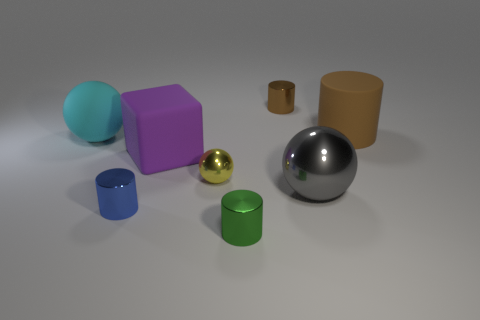What is the shape of the brown thing that is to the left of the gray metal object?
Ensure brevity in your answer.  Cylinder. Are there fewer large rubber cylinders than large yellow rubber things?
Keep it short and to the point. No. Is there anything else of the same color as the large cylinder?
Your response must be concise. Yes. What is the size of the metal cylinder left of the big purple rubber block?
Your response must be concise. Small. Is the number of big brown objects greater than the number of green matte spheres?
Your answer should be very brief. Yes. What is the small yellow sphere made of?
Keep it short and to the point. Metal. How many other objects are there of the same material as the cyan thing?
Your response must be concise. 2. How many big cyan rubber spheres are there?
Offer a terse response. 1. There is a large brown thing that is the same shape as the tiny green metallic object; what is it made of?
Your response must be concise. Rubber. Is the big ball that is behind the small ball made of the same material as the tiny green thing?
Make the answer very short. No. 